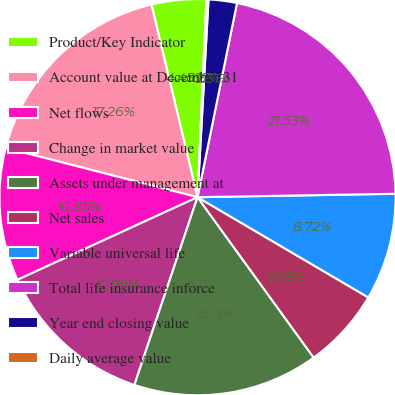Convert chart to OTSL. <chart><loc_0><loc_0><loc_500><loc_500><pie_chart><fcel>Product/Key Indicator<fcel>Account value at December 31<fcel>Net flows<fcel>Change in market value<fcel>Assets under management at<fcel>Net sales<fcel>Variable universal life<fcel>Total life insurance inforce<fcel>Year end closing value<fcel>Daily average value<nl><fcel>4.45%<fcel>17.26%<fcel>10.85%<fcel>12.99%<fcel>15.13%<fcel>6.58%<fcel>8.72%<fcel>21.53%<fcel>2.31%<fcel>0.17%<nl></chart> 